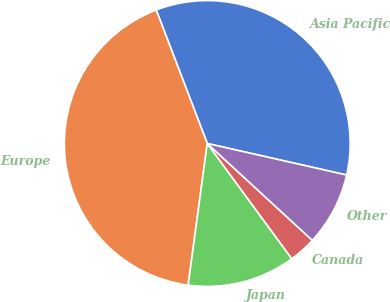Convert chart. <chart><loc_0><loc_0><loc_500><loc_500><pie_chart><fcel>Asia Pacific<fcel>Europe<fcel>Japan<fcel>Canada<fcel>Other<nl><fcel>34.35%<fcel>42.05%<fcel>12.21%<fcel>3.07%<fcel>8.31%<nl></chart> 